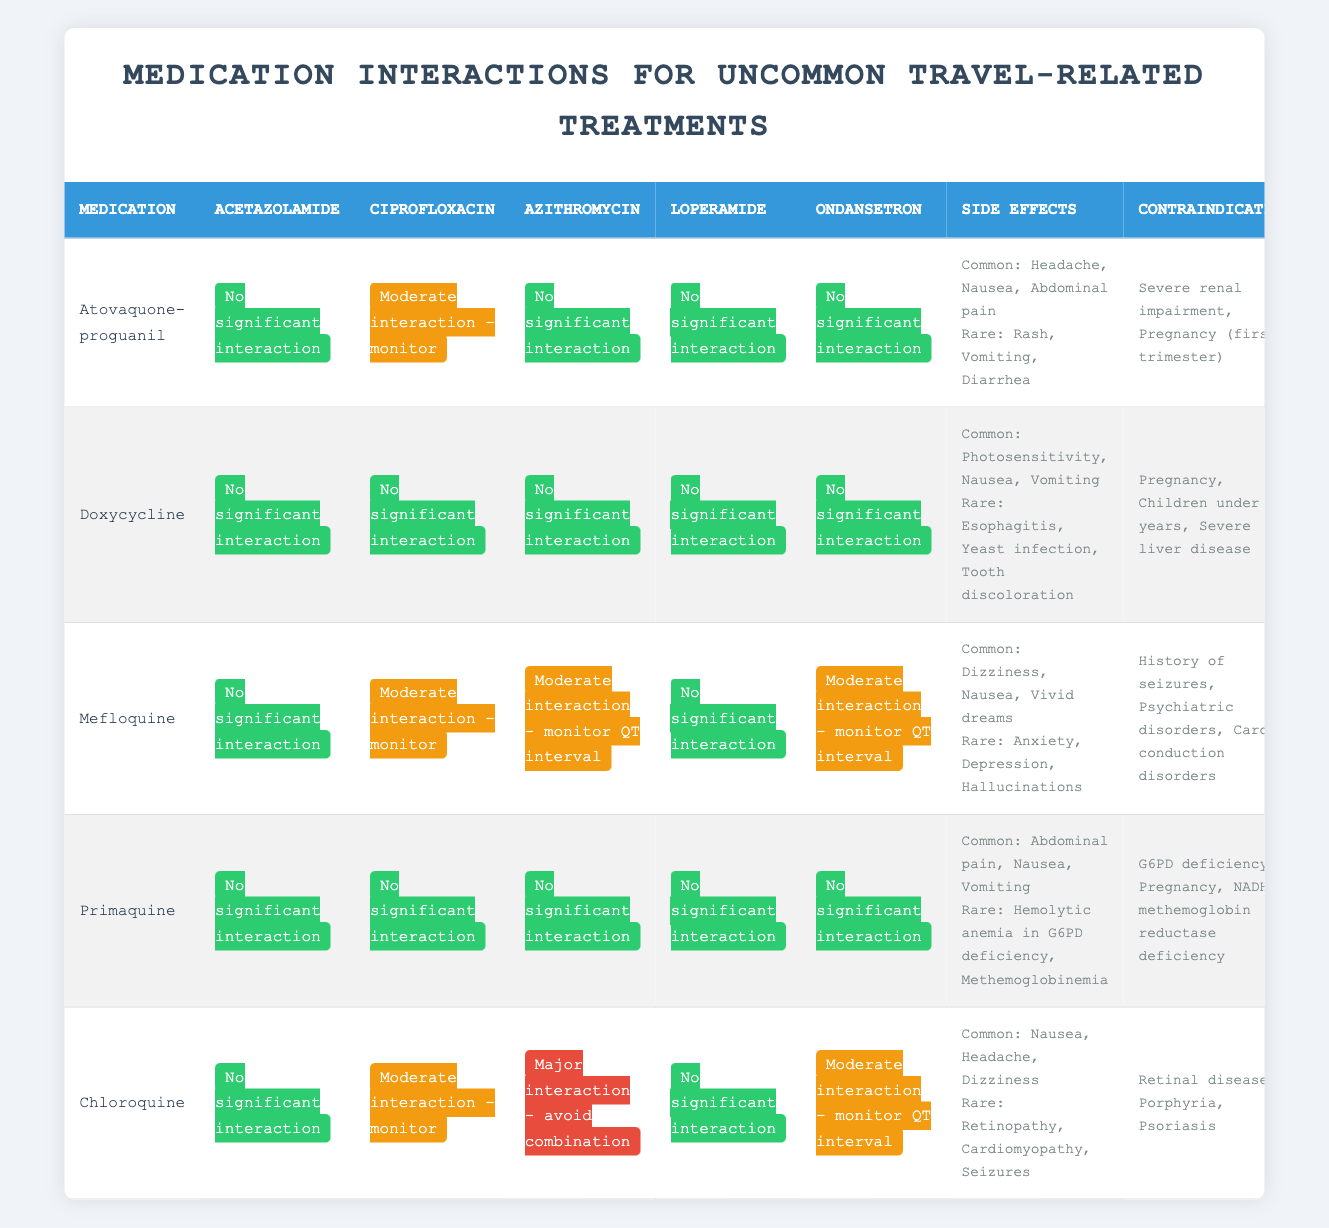What is the interaction status of Atovaquone-proguanil with Ciprofloxacin? The table indicates that Atovaquone-proguanil has a "Moderate interaction - monitor" status with Ciprofloxacin, as mentioned in the corresponding cell under the Ciprofloxacin column for Atovaquone-proguanil.
Answer: Moderate interaction - monitor Which medication has a major interaction with Azithromycin? By checking the table, I see that Chloroquine is listed with a "Major interaction - avoid combination" status in the Azithromycin column. Therefore, it is Chloroquine that has a major interaction with Azithromycin.
Answer: Chloroquine Are there any significant interactions between Doxycycline and Loperamide? The table shows that there is "No significant interaction" between Doxycycline and Loperamide, as indicated in the Doxycycline row under the Loperamide column.
Answer: No significant interaction What are the common side effects of Mefloquine? The side effects are listed under the Mefloquine row in the Side Effects column, which states, "Common: Dizziness, Nausea, Vivid dreams". Thus, those are the common side effects of Mefloquine.
Answer: Dizziness, Nausea, Vivid dreams How many medications have contraindications related to pregnancy? Reviewing the contraindications for each medication, both Atovaquone-proguanil and Doxycycline list conditions related to pregnancy. Therefore, there are two medications with this contraindication.
Answer: 2 Is Primaquine contraindicated for patients with G6PD deficiency? The table indicates that Primaquine has "G6PD deficiency" as a contraindication, found in the contraindications column for Primaquine. Hence, it is true that Primaquine is contraindicated for such patients.
Answer: Yes What are the rare side effects of Chloroquine? Referring to the Chloroquine row in the Side Effects column, the rare side effects are listed as "Retinopathy, Cardiomyopathy, Seizures". This is the information found directly under Chloroquine.
Answer: Retinopathy, Cardiomyopathy, Seizures Which medication has no significant interactions with Ondansetron? Looking through the table, I can see that Atovaquone-proguanil, Doxycycline, Primaquine, and Chloroquine all have "No significant interaction" listed for Ondansetron. Hence, there are four medications with no significant interactions with Ondansetron.
Answer: 4 